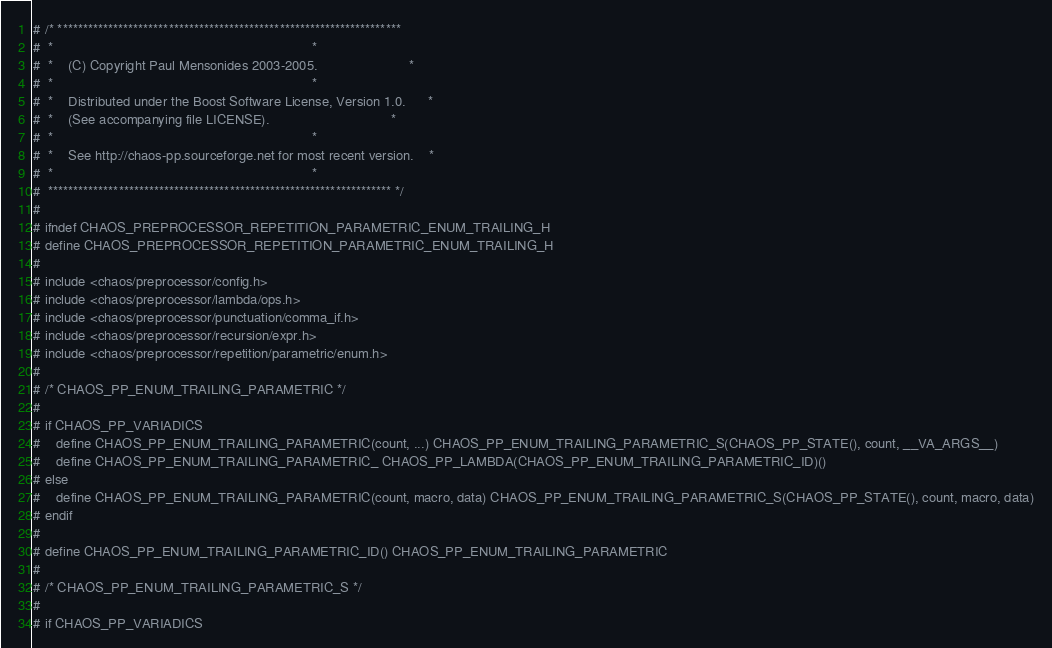<code> <loc_0><loc_0><loc_500><loc_500><_C_># /* ********************************************************************
#  *                                                                    *
#  *    (C) Copyright Paul Mensonides 2003-2005.                        *
#  *                                                                    *
#  *    Distributed under the Boost Software License, Version 1.0.      *
#  *    (See accompanying file LICENSE).                                *
#  *                                                                    *
#  *    See http://chaos-pp.sourceforge.net for most recent version.    *
#  *                                                                    *
#  ******************************************************************** */
#
# ifndef CHAOS_PREPROCESSOR_REPETITION_PARAMETRIC_ENUM_TRAILING_H
# define CHAOS_PREPROCESSOR_REPETITION_PARAMETRIC_ENUM_TRAILING_H
#
# include <chaos/preprocessor/config.h>
# include <chaos/preprocessor/lambda/ops.h>
# include <chaos/preprocessor/punctuation/comma_if.h>
# include <chaos/preprocessor/recursion/expr.h>
# include <chaos/preprocessor/repetition/parametric/enum.h>
#
# /* CHAOS_PP_ENUM_TRAILING_PARAMETRIC */
#
# if CHAOS_PP_VARIADICS
#    define CHAOS_PP_ENUM_TRAILING_PARAMETRIC(count, ...) CHAOS_PP_ENUM_TRAILING_PARAMETRIC_S(CHAOS_PP_STATE(), count, __VA_ARGS__)
#    define CHAOS_PP_ENUM_TRAILING_PARAMETRIC_ CHAOS_PP_LAMBDA(CHAOS_PP_ENUM_TRAILING_PARAMETRIC_ID)()
# else
#    define CHAOS_PP_ENUM_TRAILING_PARAMETRIC(count, macro, data) CHAOS_PP_ENUM_TRAILING_PARAMETRIC_S(CHAOS_PP_STATE(), count, macro, data)
# endif
#
# define CHAOS_PP_ENUM_TRAILING_PARAMETRIC_ID() CHAOS_PP_ENUM_TRAILING_PARAMETRIC
#
# /* CHAOS_PP_ENUM_TRAILING_PARAMETRIC_S */
#
# if CHAOS_PP_VARIADICS</code> 